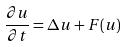<formula> <loc_0><loc_0><loc_500><loc_500>\frac { \partial u } { \partial t } = \Delta u + F ( u )</formula> 